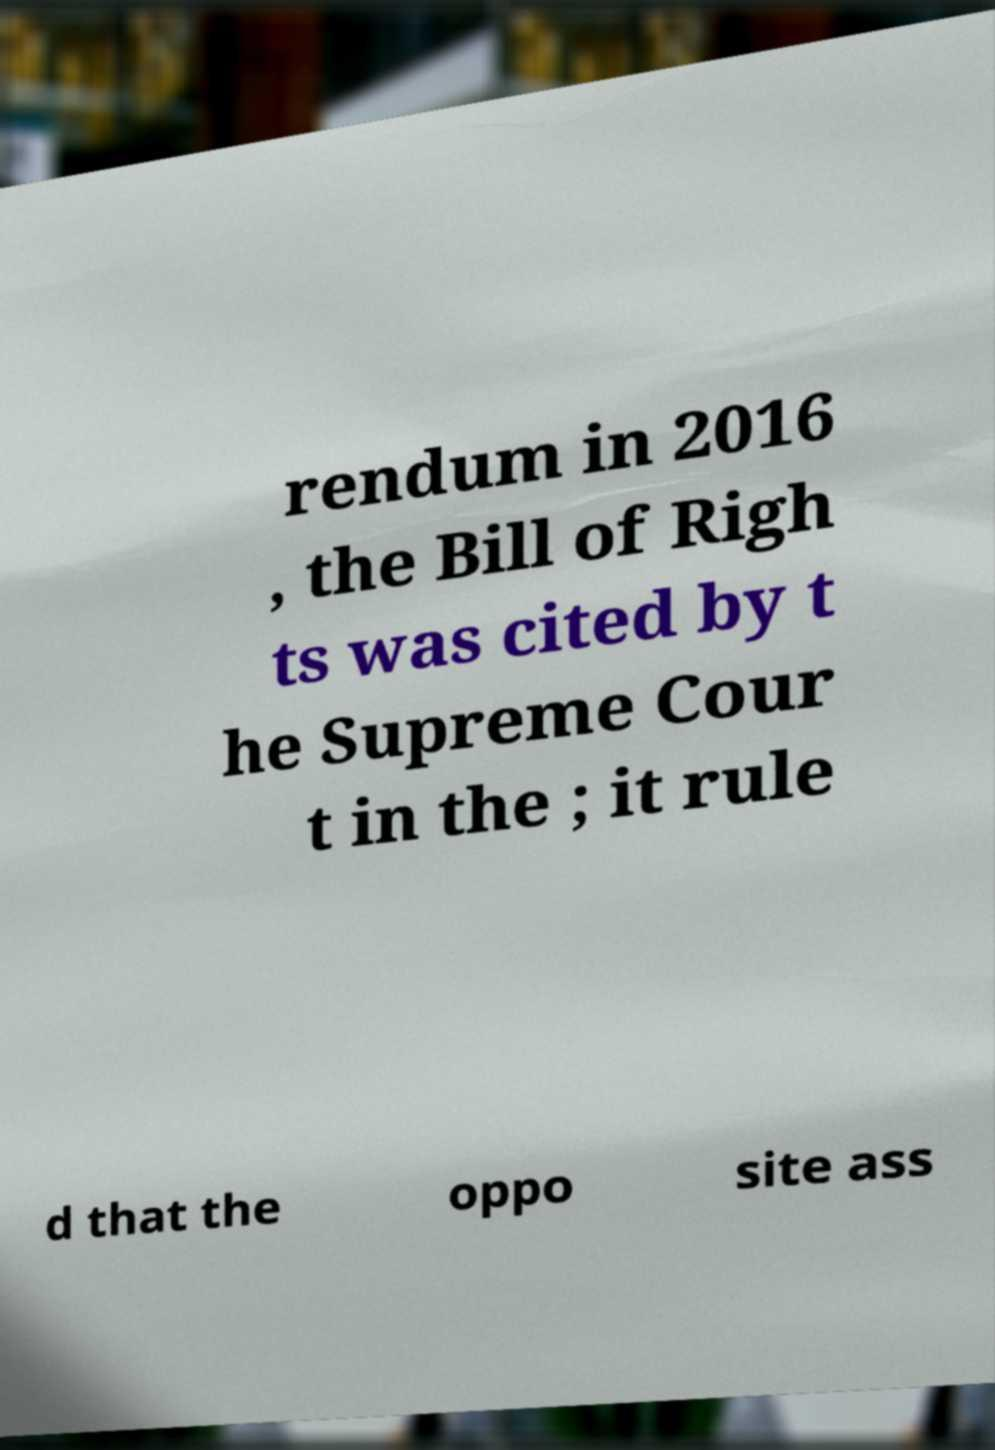Can you accurately transcribe the text from the provided image for me? rendum in 2016 , the Bill of Righ ts was cited by t he Supreme Cour t in the ; it rule d that the oppo site ass 